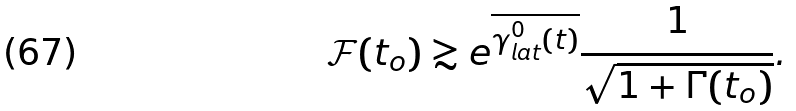<formula> <loc_0><loc_0><loc_500><loc_500>\mathcal { F } ( t _ { o } ) \gtrsim e ^ { \overline { \gamma _ { l a t } ^ { 0 } ( t ) } } \frac { 1 } { \sqrt { 1 + \Gamma ( t _ { o } ) } } .</formula> 